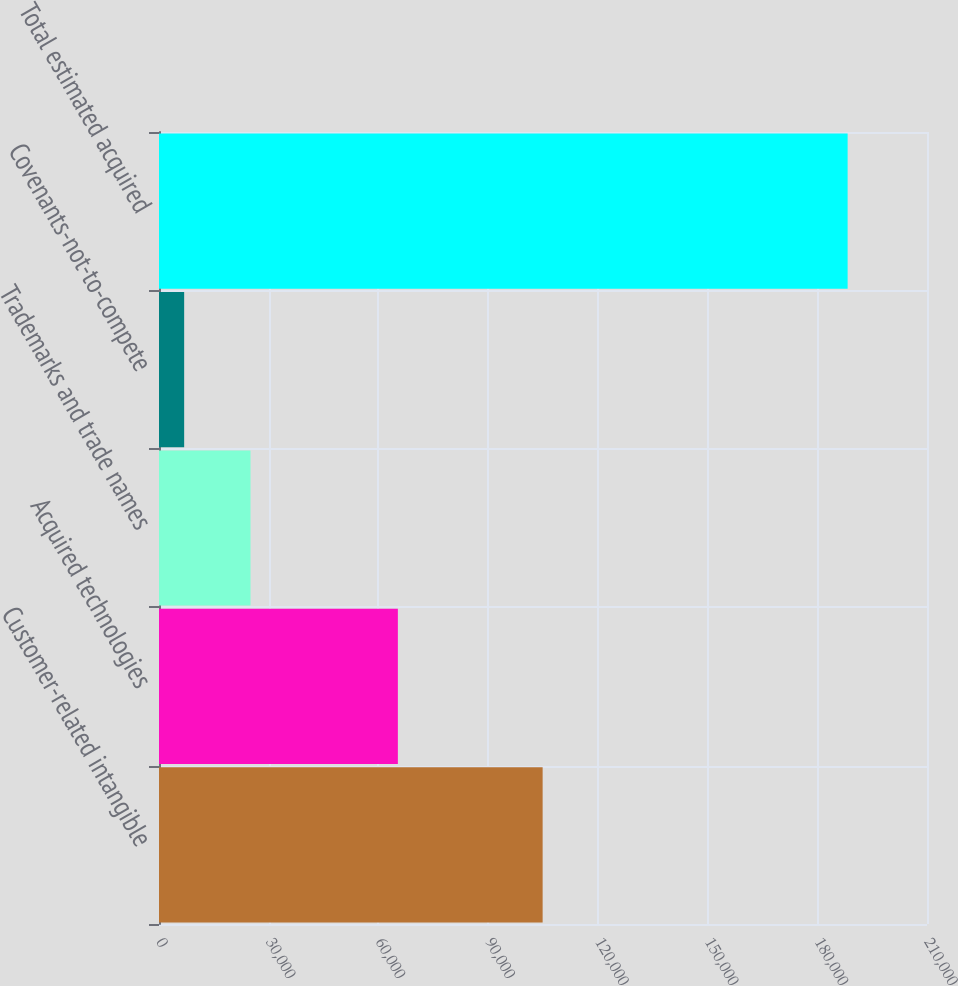Convert chart to OTSL. <chart><loc_0><loc_0><loc_500><loc_500><bar_chart><fcel>Customer-related intangible<fcel>Acquired technologies<fcel>Trademarks and trade names<fcel>Covenants-not-to-compete<fcel>Total estimated acquired<nl><fcel>104900<fcel>65312<fcel>25021.4<fcel>6880<fcel>188294<nl></chart> 